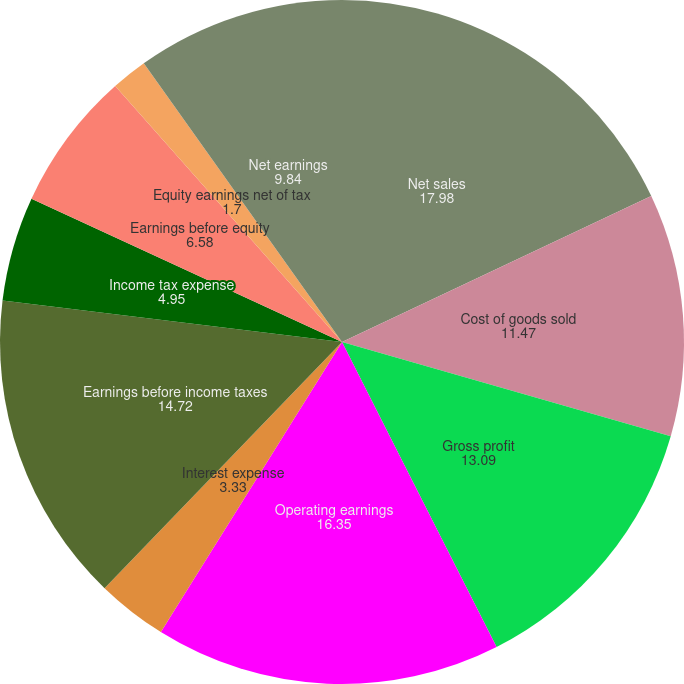<chart> <loc_0><loc_0><loc_500><loc_500><pie_chart><fcel>Net sales<fcel>Cost of goods sold<fcel>Gross profit<fcel>Operating earnings<fcel>Interest expense<fcel>Earnings before income taxes<fcel>Income tax expense<fcel>Earnings before equity<fcel>Equity earnings net of tax<fcel>Net earnings<nl><fcel>17.98%<fcel>11.47%<fcel>13.09%<fcel>16.35%<fcel>3.33%<fcel>14.72%<fcel>4.95%<fcel>6.58%<fcel>1.7%<fcel>9.84%<nl></chart> 